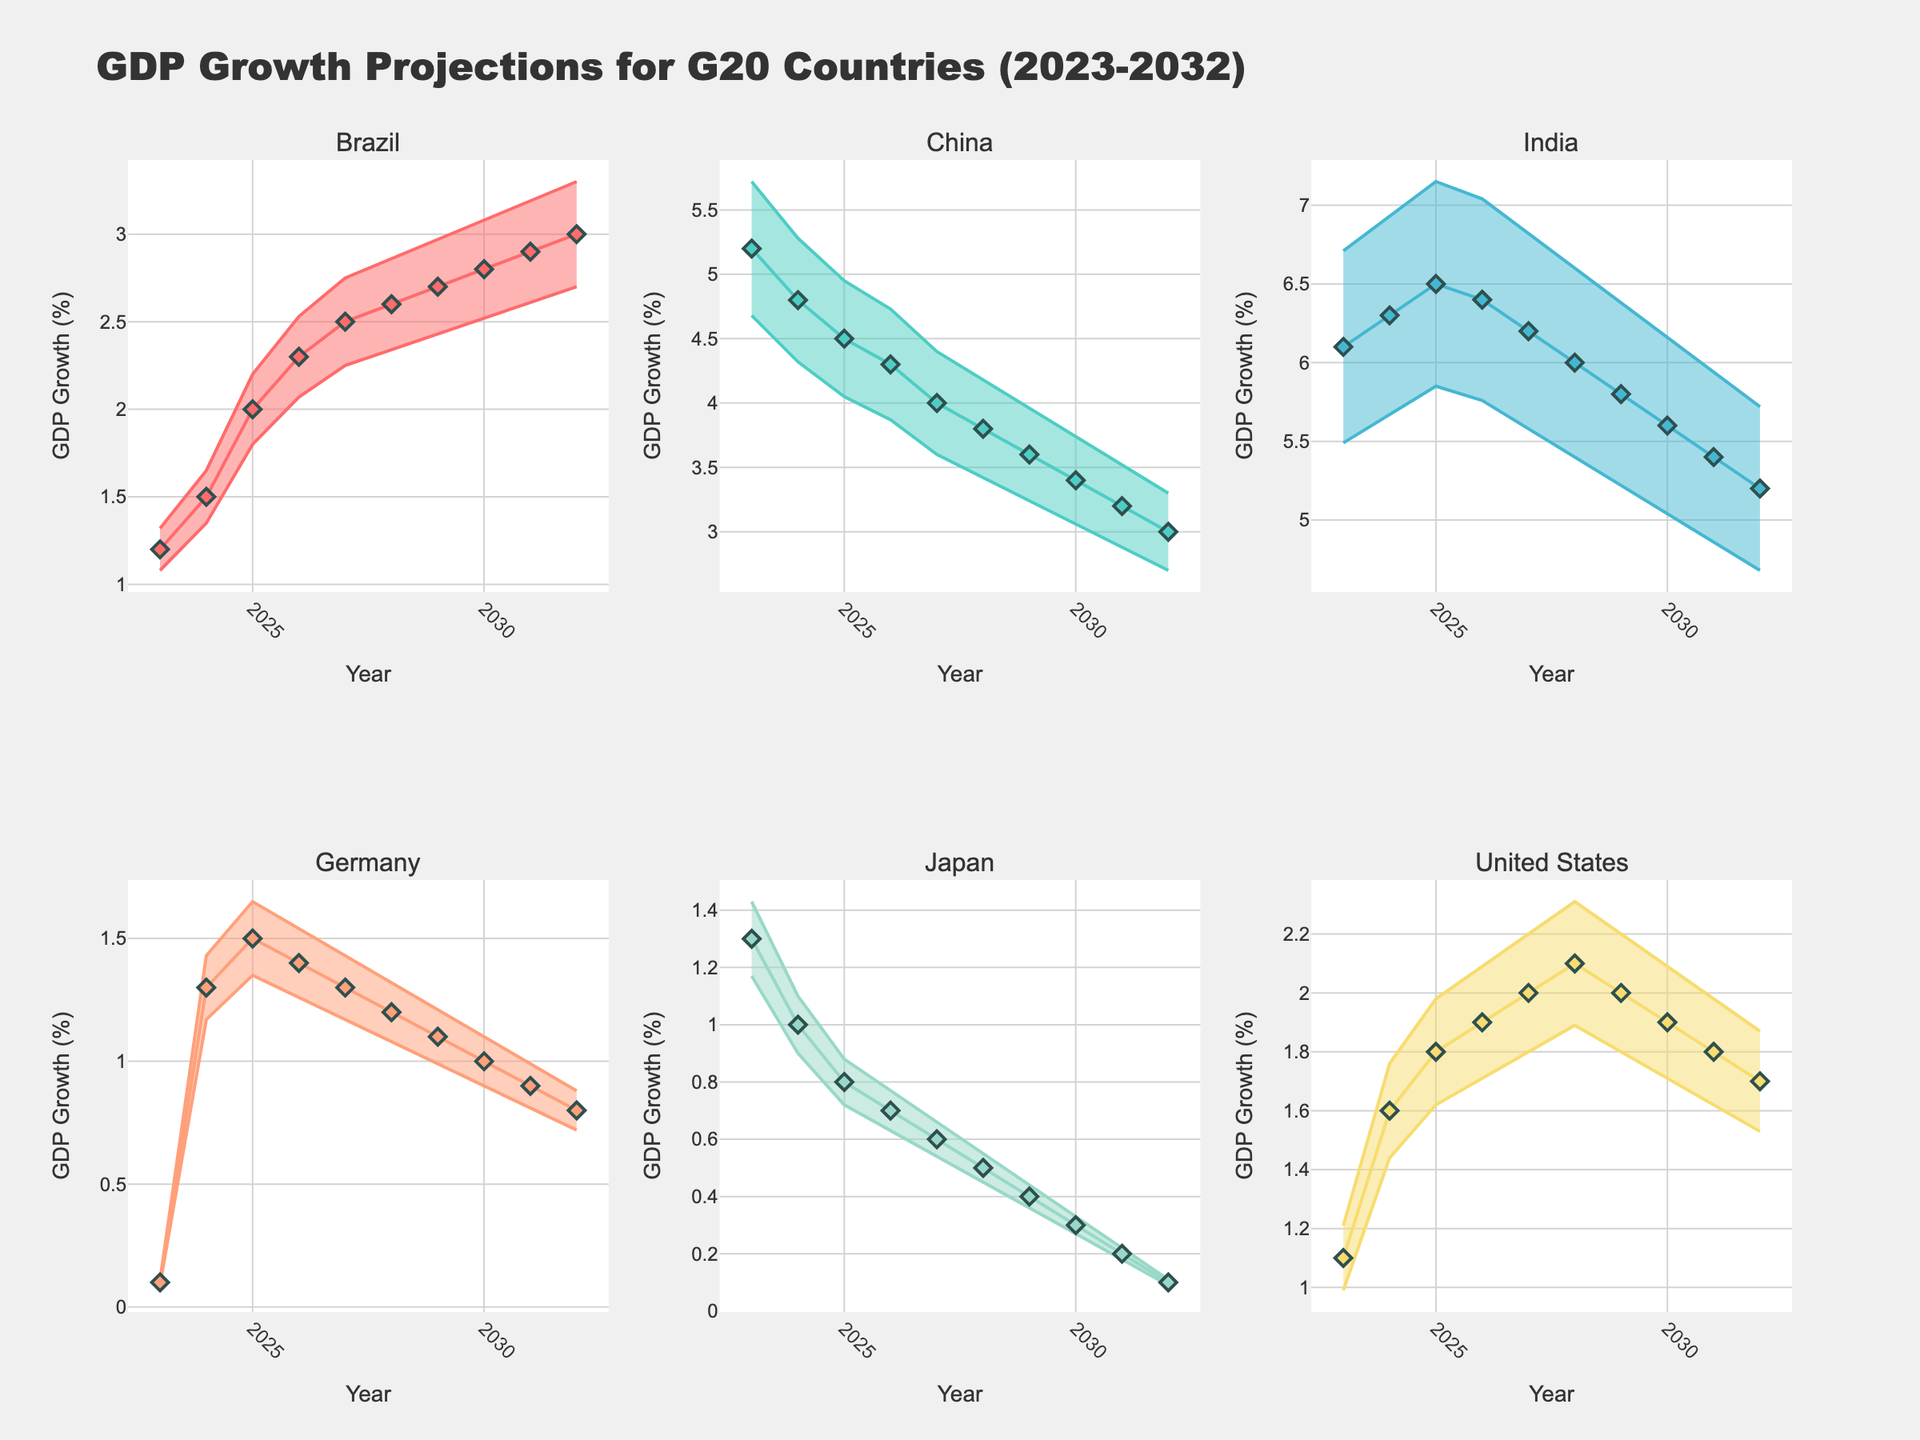What is the projected GDP growth for China in 2025? Look at the data point for China in 2025 on the plot. The projected GDP growth is marked as a data point along the line.
Answer: 4.5% What is the range of the confidence interval for Brazil's GDP growth in 2030? Note the shaded area around the line for Brazil in 2030. The upper bound is 2.8 + 0.28, and the lower bound is 2.8 - 0.28. Thus, the range is from 2.52 to 3.08.
Answer: 2.52% to 3.08% Which country is projected to have the highest GDP growth in 2030? Compare the data points for all countries in 2030. The country with the highest data point is India.
Answer: India How does the projected GDP growth for Germany in 2027 compare to Japan in the same year? Look at the data points for Germany and Japan in 2027. Germany's GDP growth is 1.3%, while Japan's is 0.6%. Germany's is higher.
Answer: Germany's is higher Has the projected GDP growth for India generally increased, decreased, or remained constant over the decade? Observe the trend line for India from 2023 to 2032. The line shows a decreasing trend.
Answer: Decreased What is the average projected GDP growth for the United States over the last three years (2030-2032)? Add the GDP growth values for the United States in 2030, 2031, and 2032 and divide by 3. The values are 1.9, 1.8, and 1.7, so (1.9+1.8+1.7)/3 = 1.8.
Answer: 1.8% Which two countries have overlapping confidence intervals in 2024? Look at the shaded areas for all countries in 2024. The confidence intervals for Brazil and Germany overlap.
Answer: Brazil and Germany What is the overall trend in GDP growth for Japan from 2023 to 2032? Observe the specific trend line for Japan over the decade. The line slightly declines over time.
Answer: Decline How much higher is the upper bound of India's GDP growth compared to the upper bound of Germany's in 2025? Calculate the difference between the upper bounds in 2025. India's upper bound is 6.5 + 0.65 and Germany's is 1.5 + 0.15. So, 7.15 - 1.65 = 5.5.
Answer: 5.5% Which country shows the least variability in its GDP growth projections over the decade? Compare the width of the confidence intervals' shaded areas for each country. Japan's confidence interval has the narrowest range, indicating the least variability.
Answer: Japan 